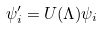<formula> <loc_0><loc_0><loc_500><loc_500>\psi _ { i } ^ { \prime } = U ( \Lambda ) \psi _ { i }</formula> 